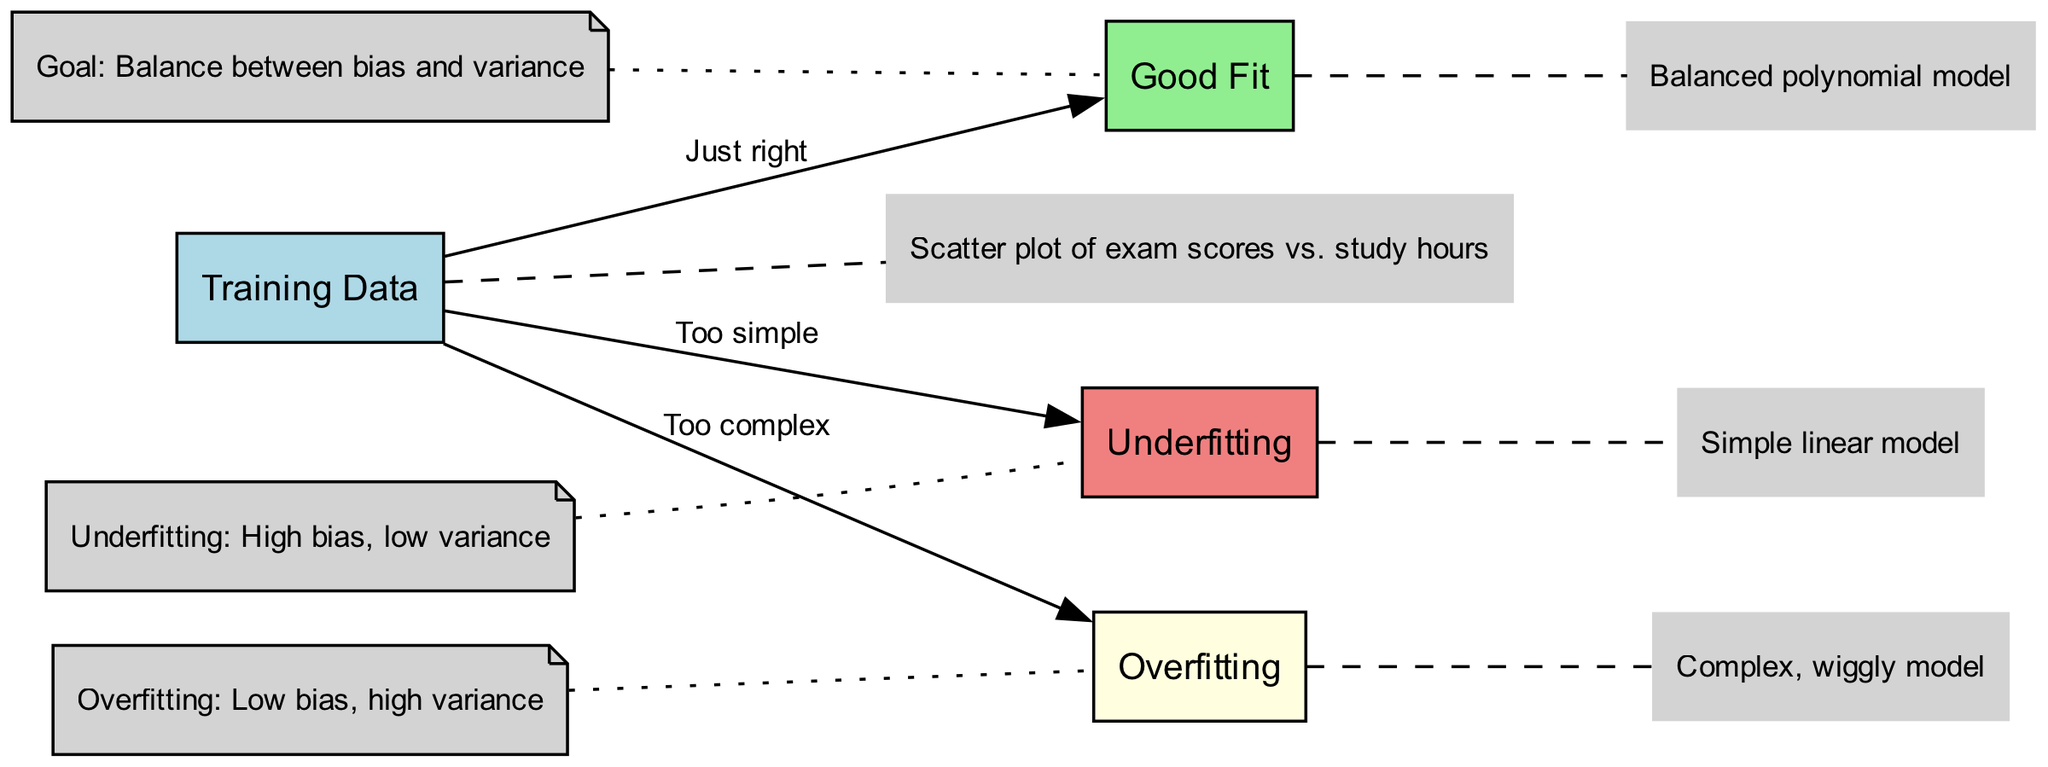What is the label of the node representing the model with a simple linear representation? The node displaying the simplest model in the diagram is labeled "Underfitting." It is specifically depicted as a simple linear model.
Answer: Underfitting How many nodes are present in the diagram? By counting the distinct nodes outlined – Training Data, Underfitting, Good Fit, and Overfitting – we find that there are four nodes in total.
Answer: Four Which model is indicated as "Just right"? The model that achieves a balance between complexity and accuracy is labeled "Good Fit," representing a polynomial model that adequately fits the data without overcomplicating it.
Answer: Good Fit What is the characteristic of overfitting according to the annotations? The annotation connected to the overfitting node describes it as having "Low bias, high variance." This means that the model is too complex and reacts excessively to small fluctuations in the training data.
Answer: Low bias, high variance What is the type of relationship between the "Training Data" node and the "Underfitting" node? The relationship illustrated with an edge and labeled "Too simple" signifies that the model being represented by the Underfitting node fails to capture the underlying patterns present in the Training Data adequately.
Answer: Too simple What is the overall goal when dealing with bias and variance in model training? The annotation associated with the "Good Fit" node establishes the objective when training machine learning models: to strike a balance between bias and variance to enhance model performance without compromising generalization.
Answer: Balance between bias and variance 